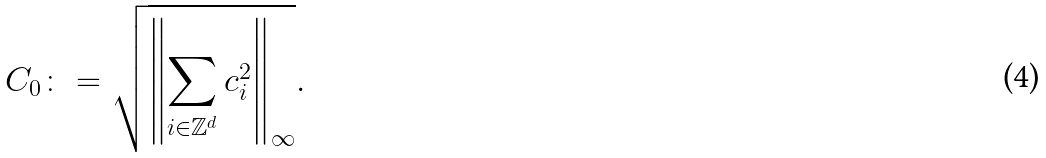Convert formula to latex. <formula><loc_0><loc_0><loc_500><loc_500>C _ { 0 } \colon = \sqrt { \left \| \sum _ { i \in \mathbb { Z } ^ { d } } c _ { i } ^ { 2 } \right \| _ { \infty } } .</formula> 